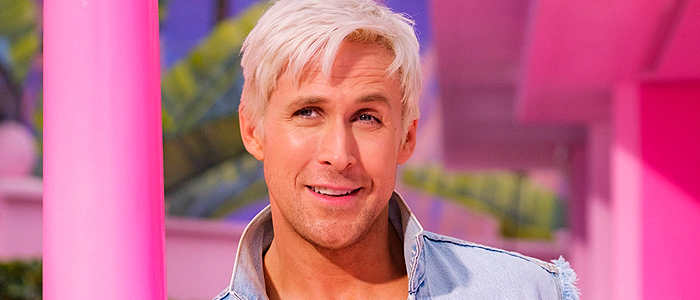What do you see happening in this image? In this image, we see a man standing against a lively, colorful background composed of pink and yellow hues. Positioned slightly to the right, he leans casually next to a pink pole visible on the left. The man wears a light blue denim jacket over a white shirt, which complements his striking blonde hair. He looks directly into the camera with a faint, engaging smile, exuding a serene and inviting demeanor. 